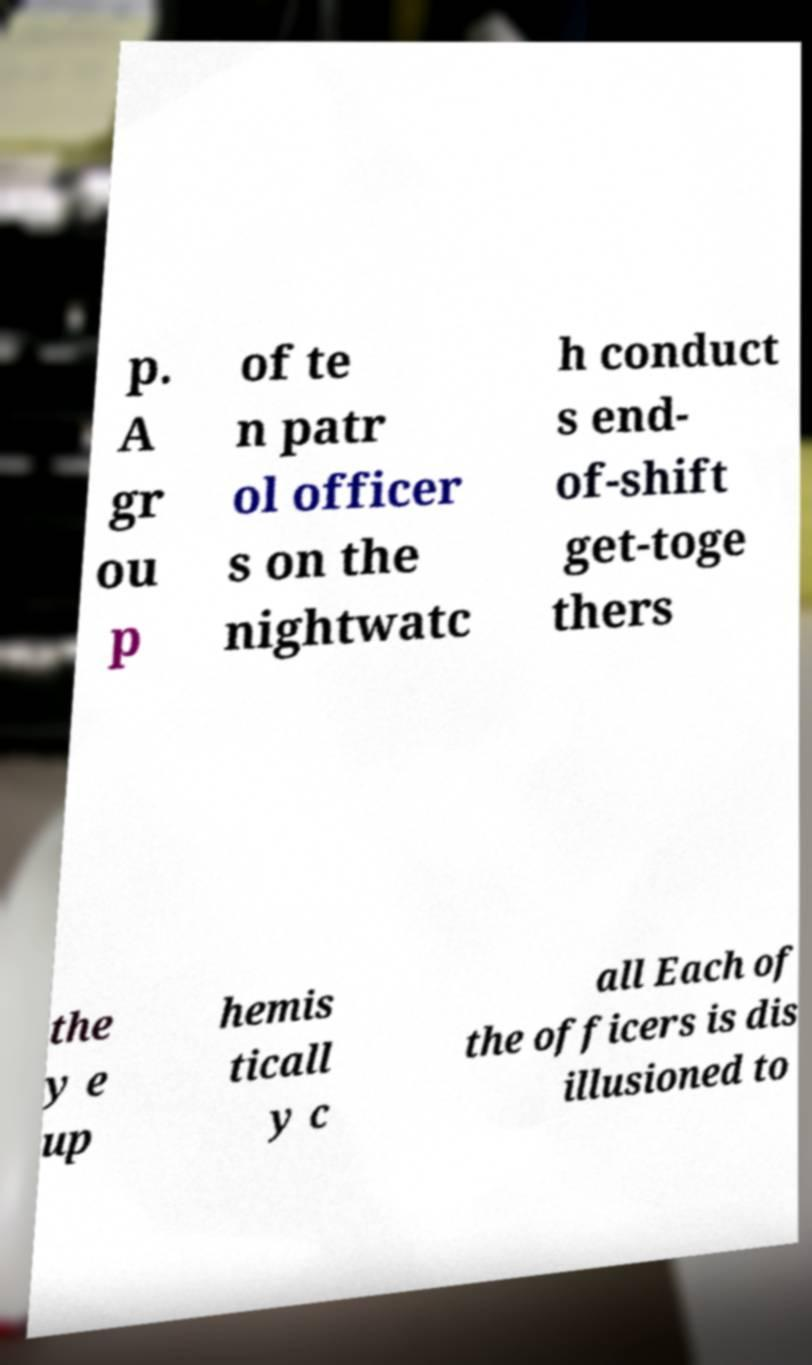Could you extract and type out the text from this image? p. A gr ou p of te n patr ol officer s on the nightwatc h conduct s end- of-shift get-toge thers the y e up hemis ticall y c all Each of the officers is dis illusioned to 